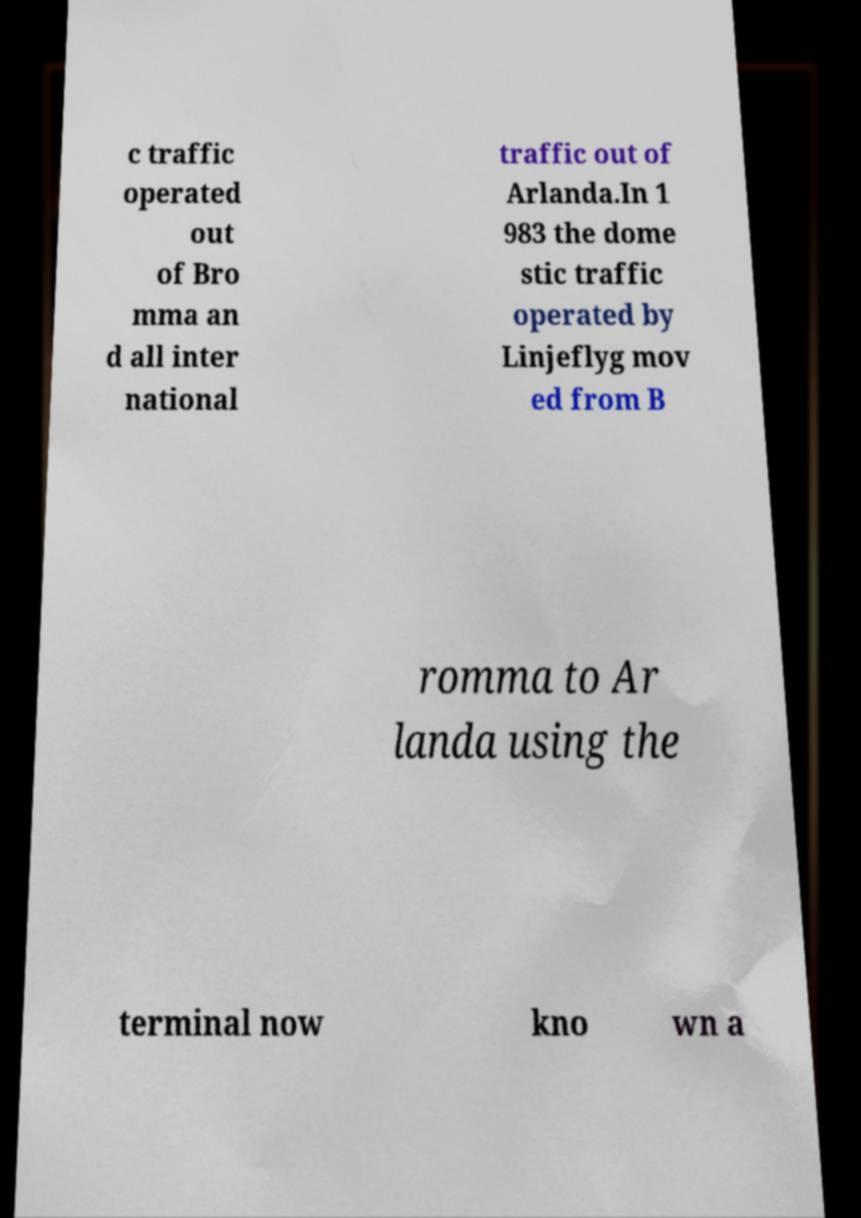What messages or text are displayed in this image? I need them in a readable, typed format. c traffic operated out of Bro mma an d all inter national traffic out of Arlanda.In 1 983 the dome stic traffic operated by Linjeflyg mov ed from B romma to Ar landa using the terminal now kno wn a 